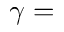Convert formula to latex. <formula><loc_0><loc_0><loc_500><loc_500>\gamma =</formula> 